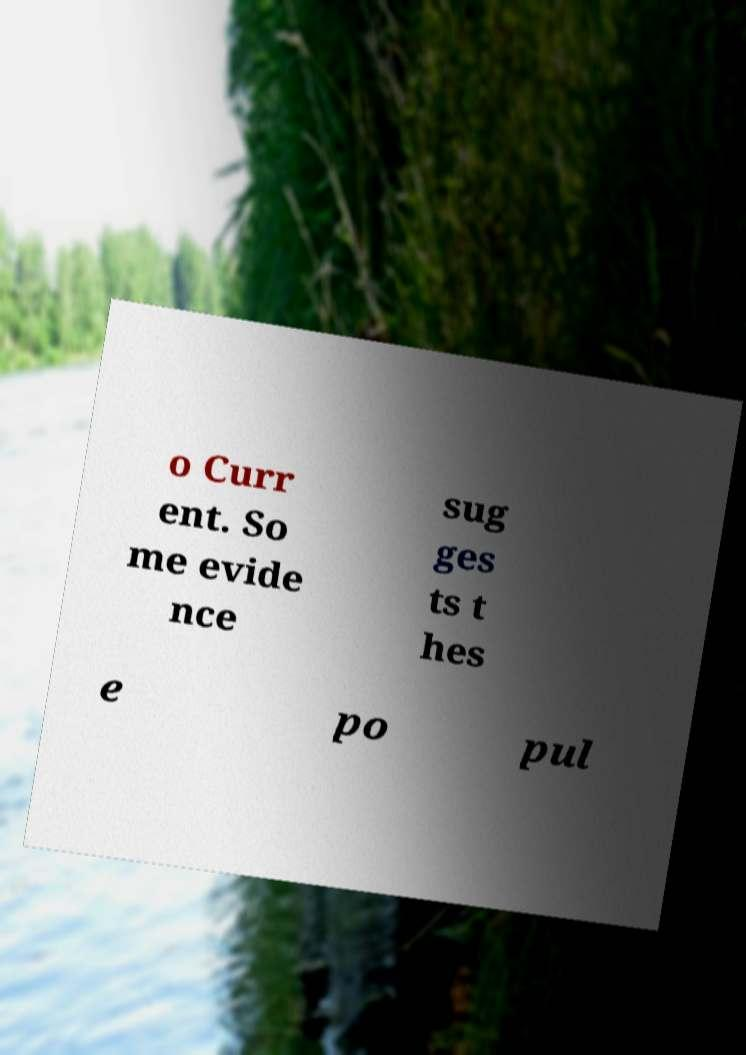For documentation purposes, I need the text within this image transcribed. Could you provide that? o Curr ent. So me evide nce sug ges ts t hes e po pul 